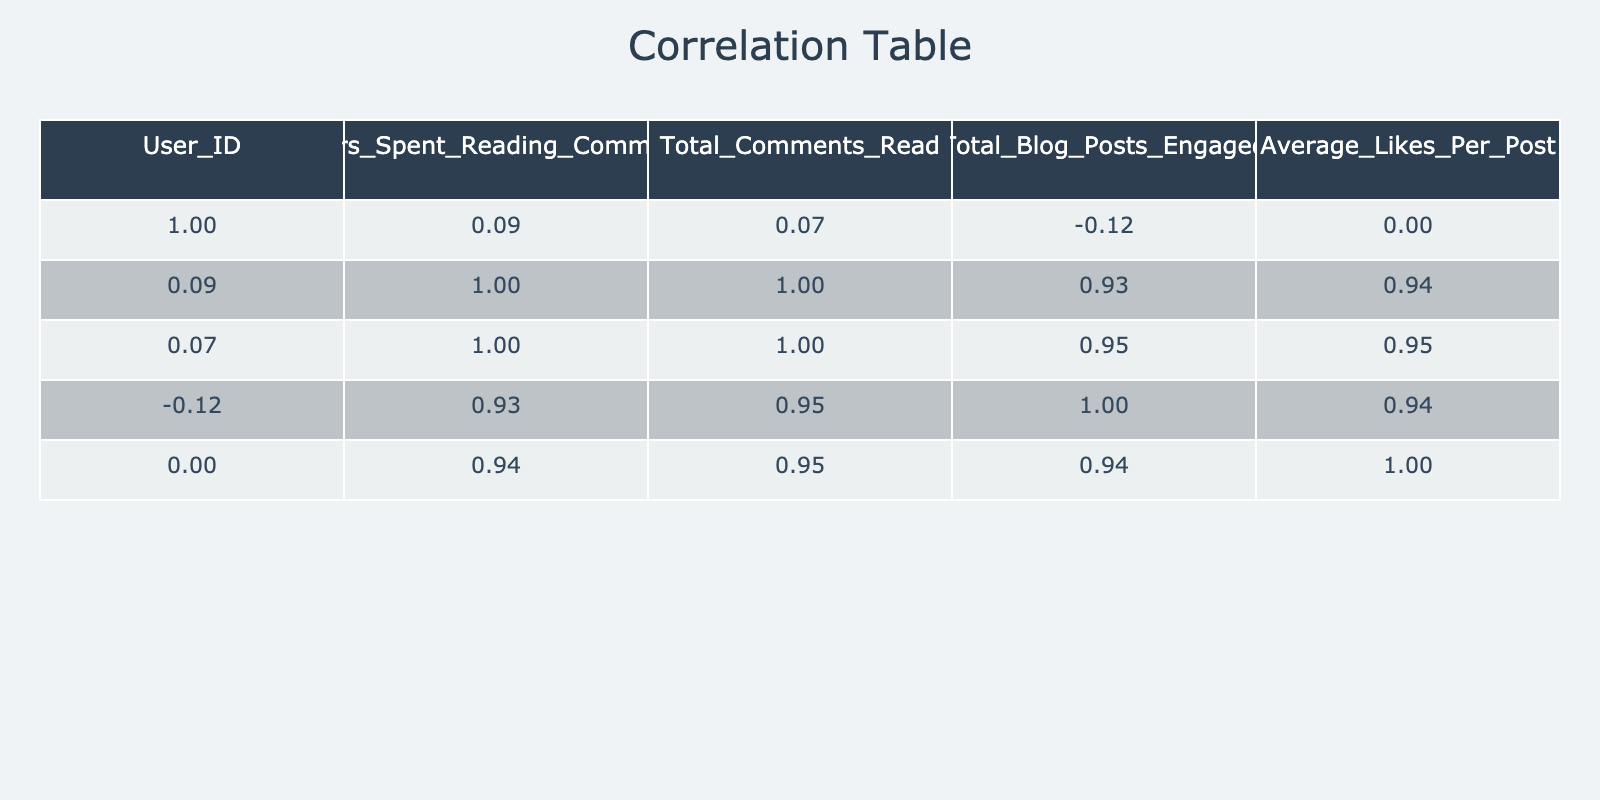What is the correlation between hours spent reading comments and total blog posts engaged? In the correlation table, we look for the value in the row for "Hours_Spent_Reading_Comments" and the column for "Total_Blog_Posts_Engaged". That value is 0.93, indicating a very strong positive correlation.
Answer: 0.93 Which user spent the most time reading comments? By examining the "Hours_Spent_Reading_Comments" column, user ID 5 has the highest value at 5 hours.
Answer: User ID 5 Is there a user who spent no time reading comments? We can check the "Hours_Spent_Reading_Comments" column for a zero value. User ID 6 spent 0.5 hours, and there is no user with 0 hours.
Answer: No What is the average likes per post for users who read more than 3 hours of comments? We need to filter users who spent more than 3 hours reading comments. Their average likes per post can be calculated by taking user IDs 3, 5, 7, and 9, which have average likes of 30, 28, 22, and 35 respectively. The sum is 115, and there are 4 users. Thus, average = 115 / 4 = 28.75.
Answer: 28.75 Who read the least total comments? Checking "Total_Comments_Read", user ID 6 read the least total comments with a value of 8.
Answer: User ID 6 Is the average number of likes per post higher for users who engaged with more blog posts? We calculate the averages for users with higher engagements. For those engaging with over 10 posts (user IDs 3, 5, 9), their average likes is (30 + 28 + 35) / 3 = 31. For those with 10 or fewer posts (user IDs 1, 2, 4, 7, 8, 10), the average likes is (25 + 12 + 15 + 22 + 10 + 18) / 6 = 18. Therefore, it is true that the average likes are higher for those engaging with more blog posts.
Answer: Yes How many total comments did users who spent less than 2 hours reading comments read on average? We filter users who spent less than 2 hours, which are user IDs 2, 4, and 6. Their total comments are 15, 30, and 8 respectively. Sum = 15 + 30 + 8 = 53. The average is 53 / 3 = 17.67.
Answer: 17.67 What is the relationship between total comments read and average likes per post? We look for the correlation value between "Total_Comments_Read" and "Average_Likes_Per_Post" in the table, which is found to be 0.89, indicating a strong positive relationship.
Answer: 0.89 Is there any user who engaged in more than 12 blog posts and read less than 50 comments? We check the users; user ID 3 and 9 engaged with more than 12 blog posts, while user IDs 1 and 2 engaged with fewer blog posts. There are no instances of users engaged in more than 12 posts with fewer than 50 comments, therefore the statement is false.
Answer: No 